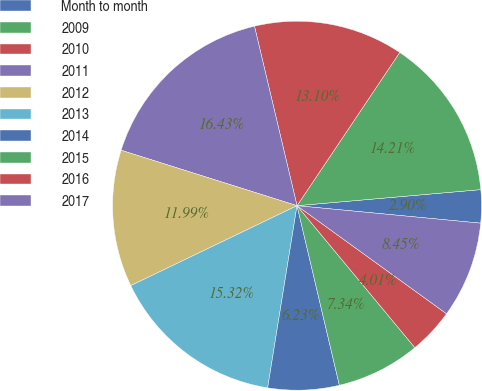Convert chart to OTSL. <chart><loc_0><loc_0><loc_500><loc_500><pie_chart><fcel>Month to month<fcel>2009<fcel>2010<fcel>2011<fcel>2012<fcel>2013<fcel>2014<fcel>2015<fcel>2016<fcel>2017<nl><fcel>2.9%<fcel>14.21%<fcel>13.1%<fcel>16.43%<fcel>11.99%<fcel>15.32%<fcel>6.23%<fcel>7.34%<fcel>4.01%<fcel>8.45%<nl></chart> 